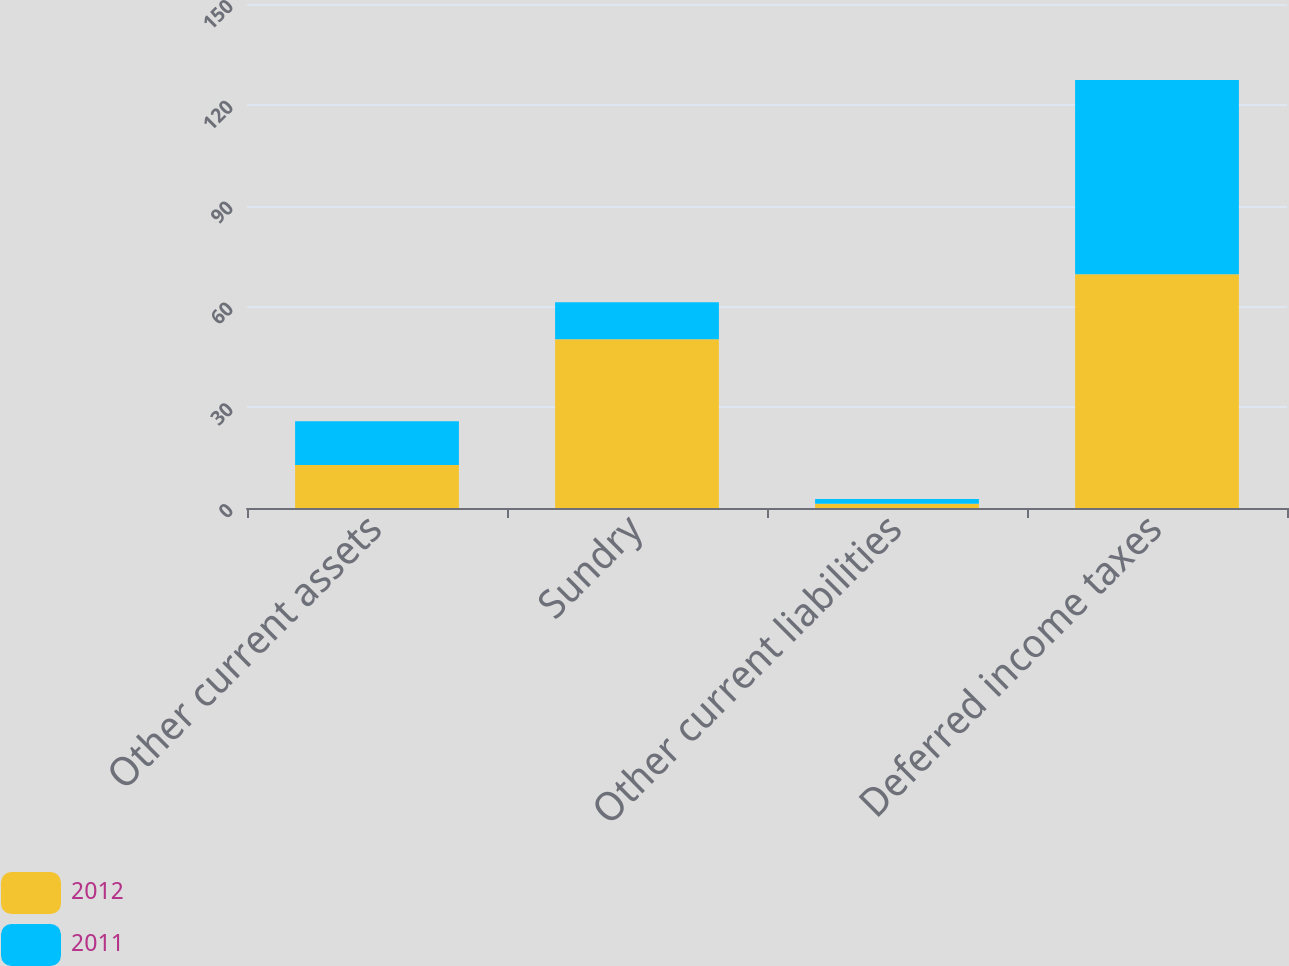Convert chart to OTSL. <chart><loc_0><loc_0><loc_500><loc_500><stacked_bar_chart><ecel><fcel>Other current assets<fcel>Sundry<fcel>Other current liabilities<fcel>Deferred income taxes<nl><fcel>2012<fcel>12.8<fcel>50.2<fcel>1.3<fcel>69.6<nl><fcel>2011<fcel>13<fcel>11<fcel>1.4<fcel>57.8<nl></chart> 